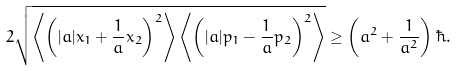Convert formula to latex. <formula><loc_0><loc_0><loc_500><loc_500>2 \sqrt { \left \langle \left ( | a | x _ { 1 } + \frac { 1 } { a } x _ { 2 } \right ) ^ { 2 } \right \rangle \left \langle \left ( | a | p _ { 1 } - \frac { 1 } { a } p _ { 2 } \right ) ^ { 2 } \right \rangle } \geq \left ( a ^ { 2 } + \frac { 1 } { a ^ { 2 } } \right ) \hbar { . }</formula> 